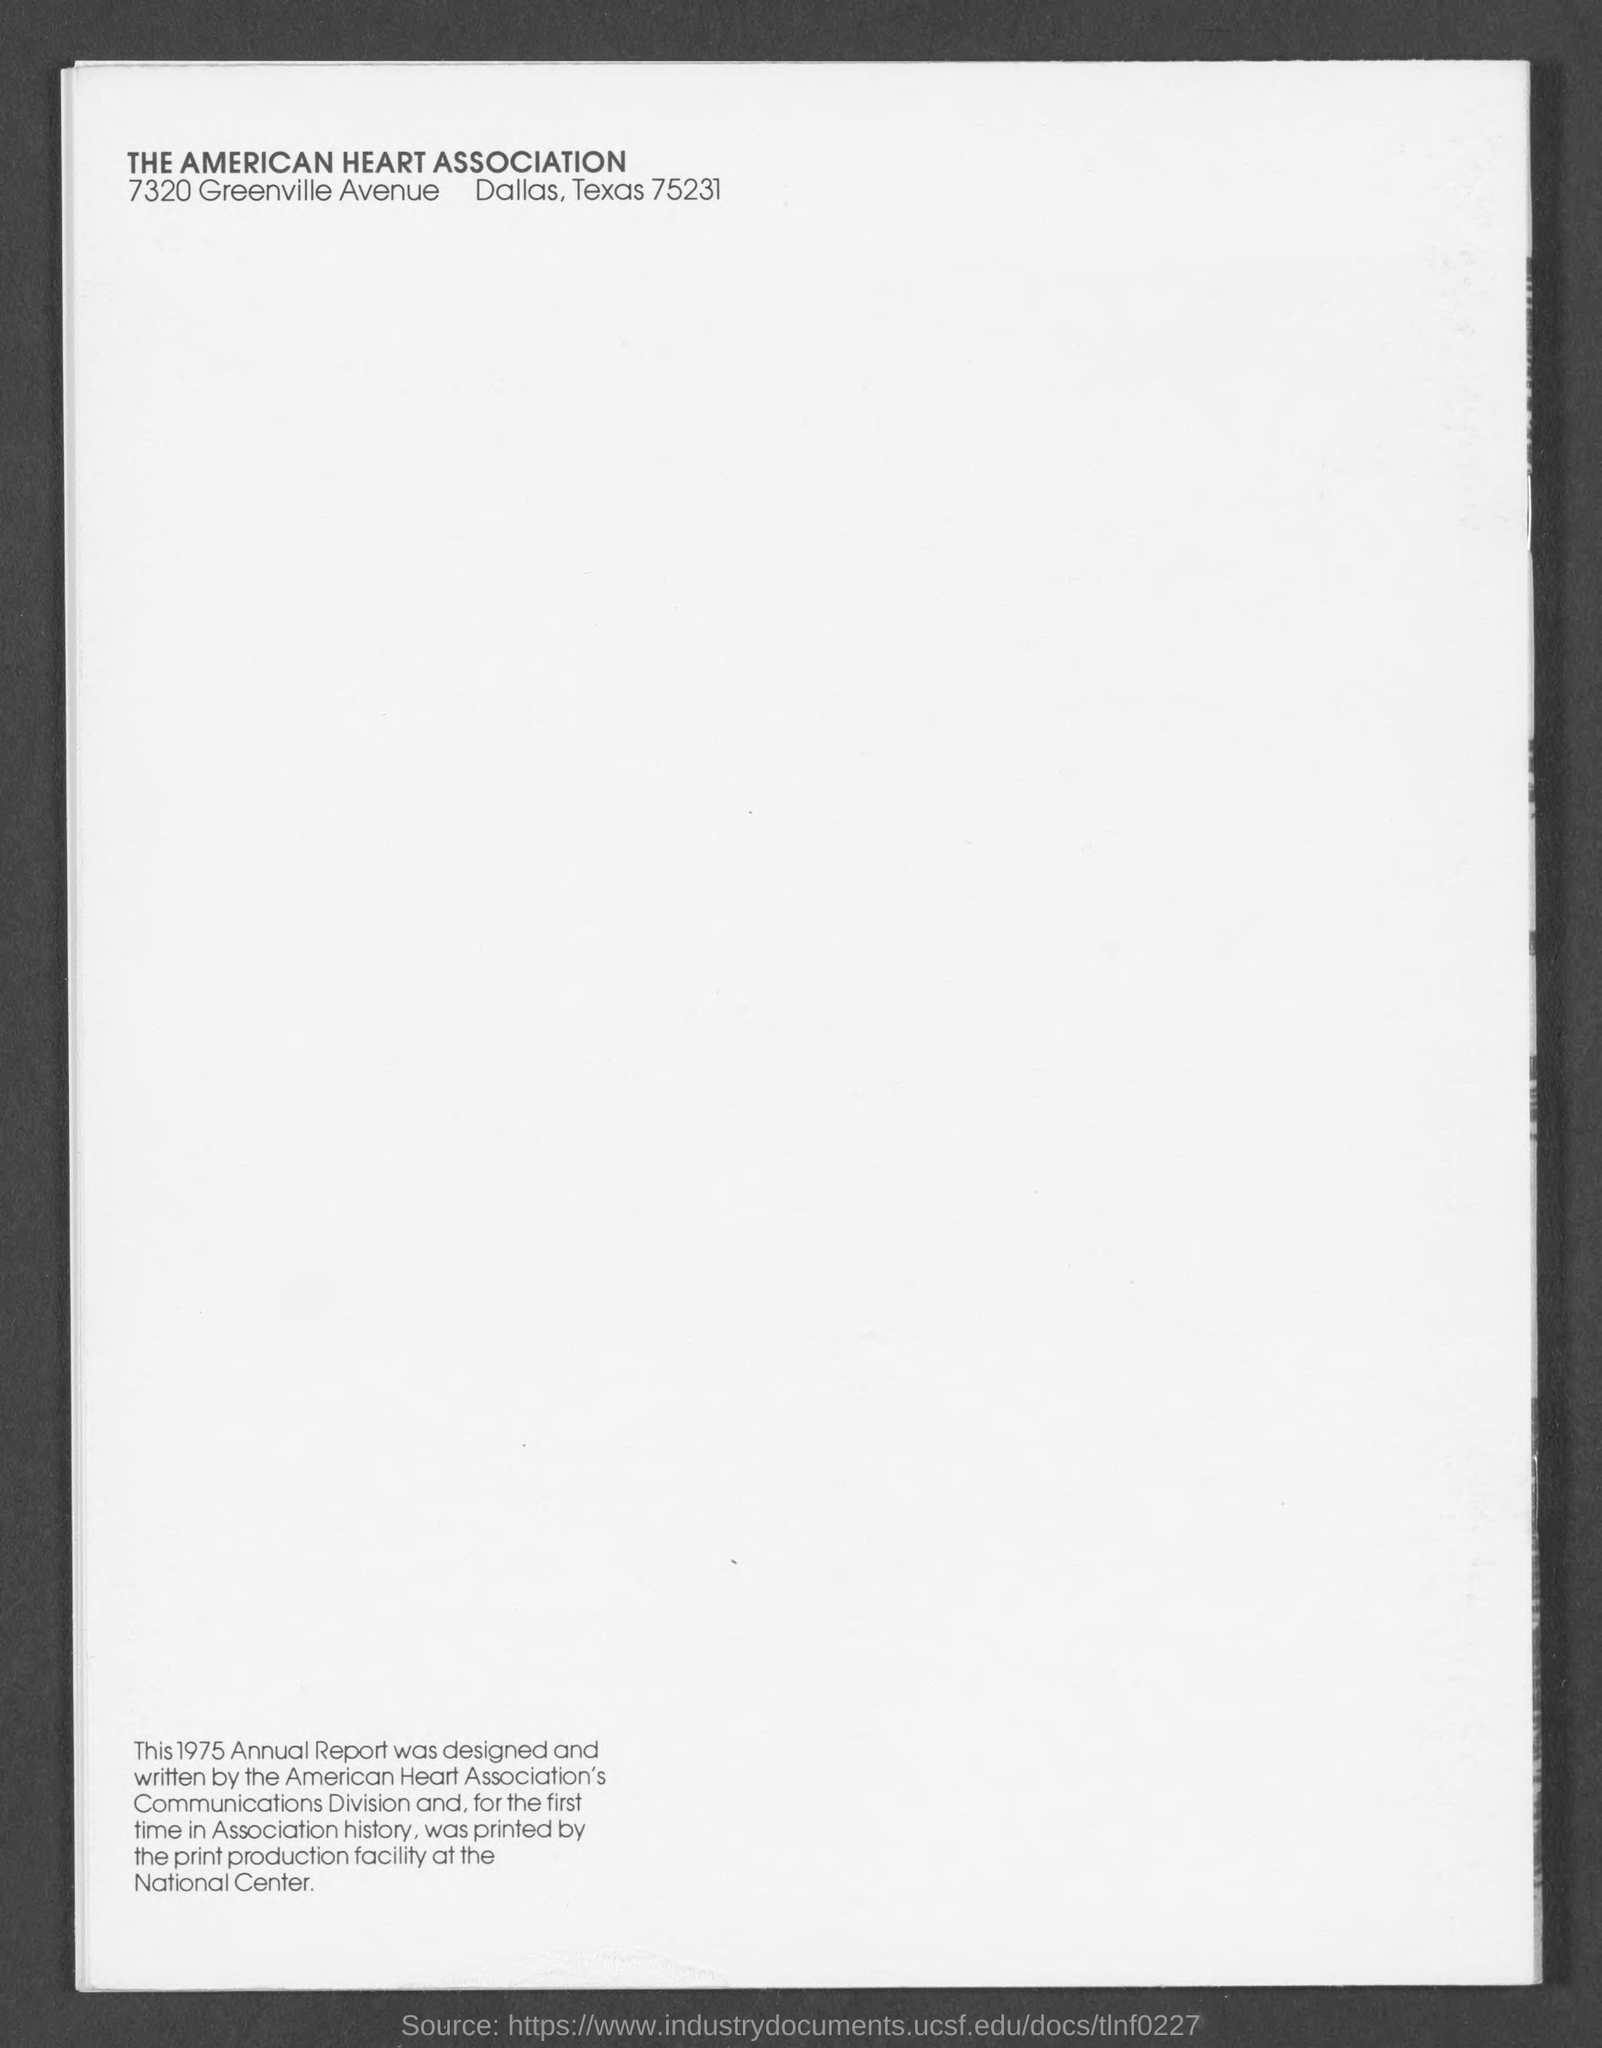What is the name of heart association ?
Your response must be concise. American heart association. In which city is the american heart association located ?
Ensure brevity in your answer.  7320 Greenville avenue. 